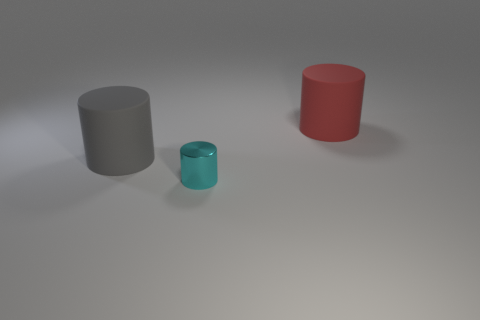How many things are big cylinders behind the gray cylinder or matte cylinders right of the large gray rubber cylinder?
Make the answer very short. 1. What size is the rubber cylinder on the left side of the big rubber object that is right of the metallic thing?
Provide a short and direct response. Large. Is the color of the big rubber cylinder that is in front of the red cylinder the same as the small cylinder?
Make the answer very short. No. Is there another tiny thing that has the same shape as the tiny cyan metallic thing?
Offer a very short reply. No. What is the color of the matte cylinder that is the same size as the red object?
Your answer should be compact. Gray. There is a matte object left of the tiny cyan shiny thing; what size is it?
Ensure brevity in your answer.  Large. Are there any shiny objects on the left side of the rubber cylinder on the left side of the red thing?
Your response must be concise. No. Are the object that is right of the cyan cylinder and the tiny cyan cylinder made of the same material?
Your answer should be very brief. No. What number of things are in front of the big red rubber cylinder and to the right of the gray cylinder?
Your answer should be very brief. 1. What number of other small objects are the same material as the tiny cyan object?
Offer a very short reply. 0. 